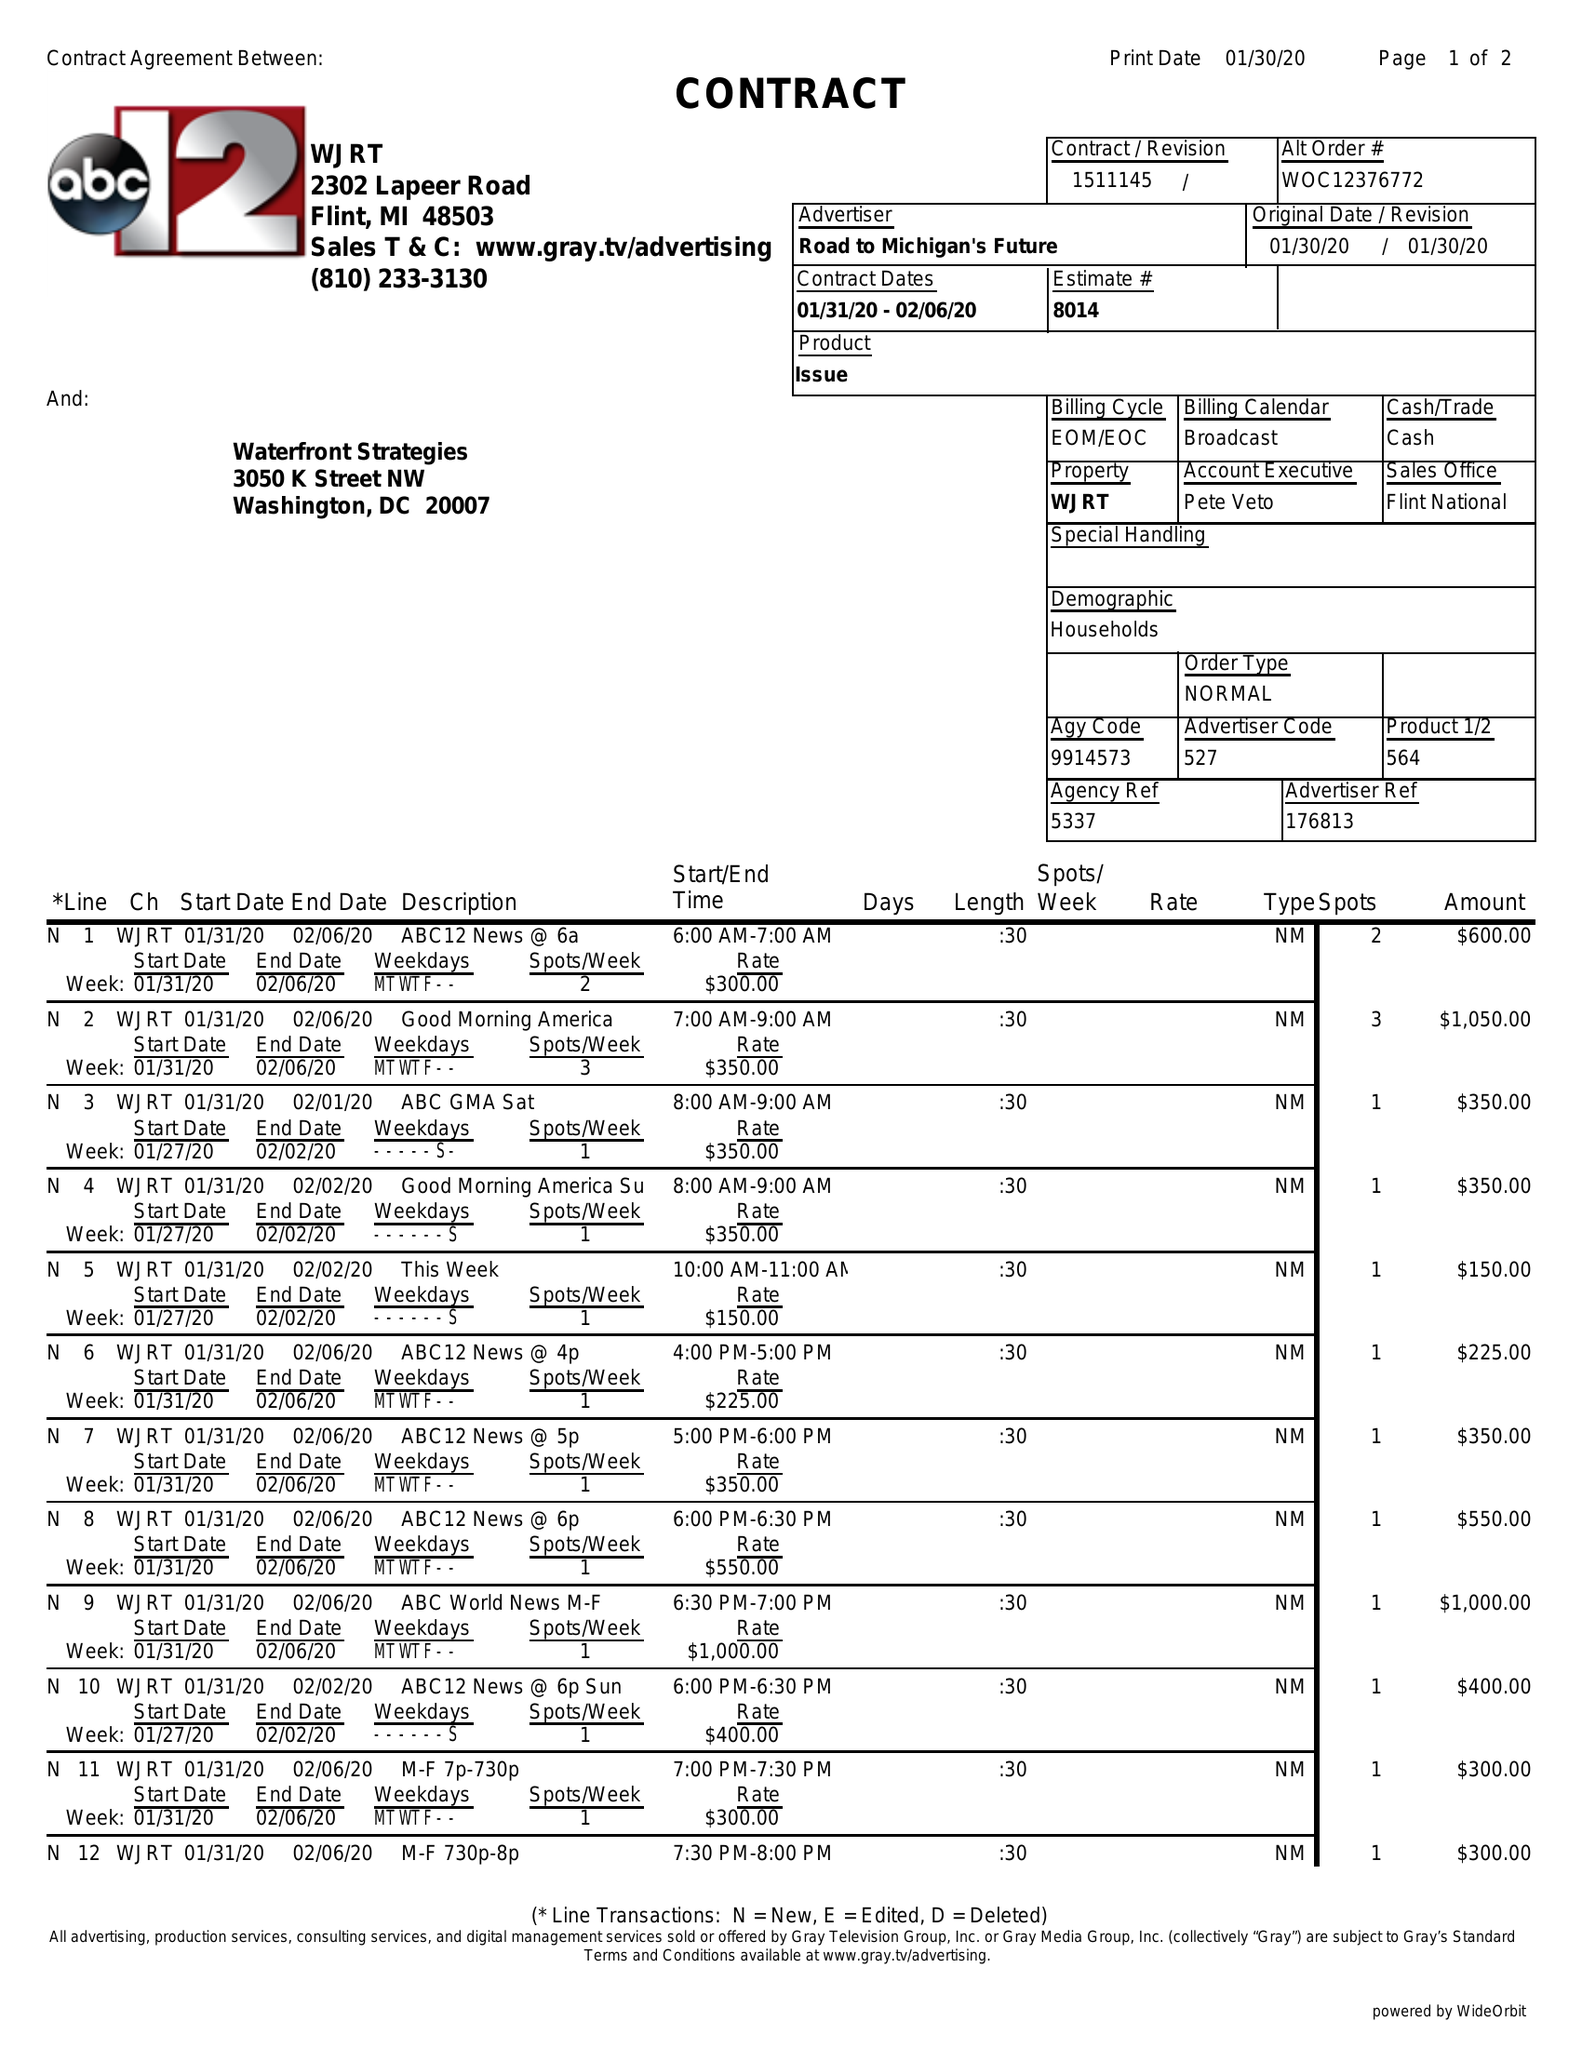What is the value for the flight_from?
Answer the question using a single word or phrase. 01/31/20 